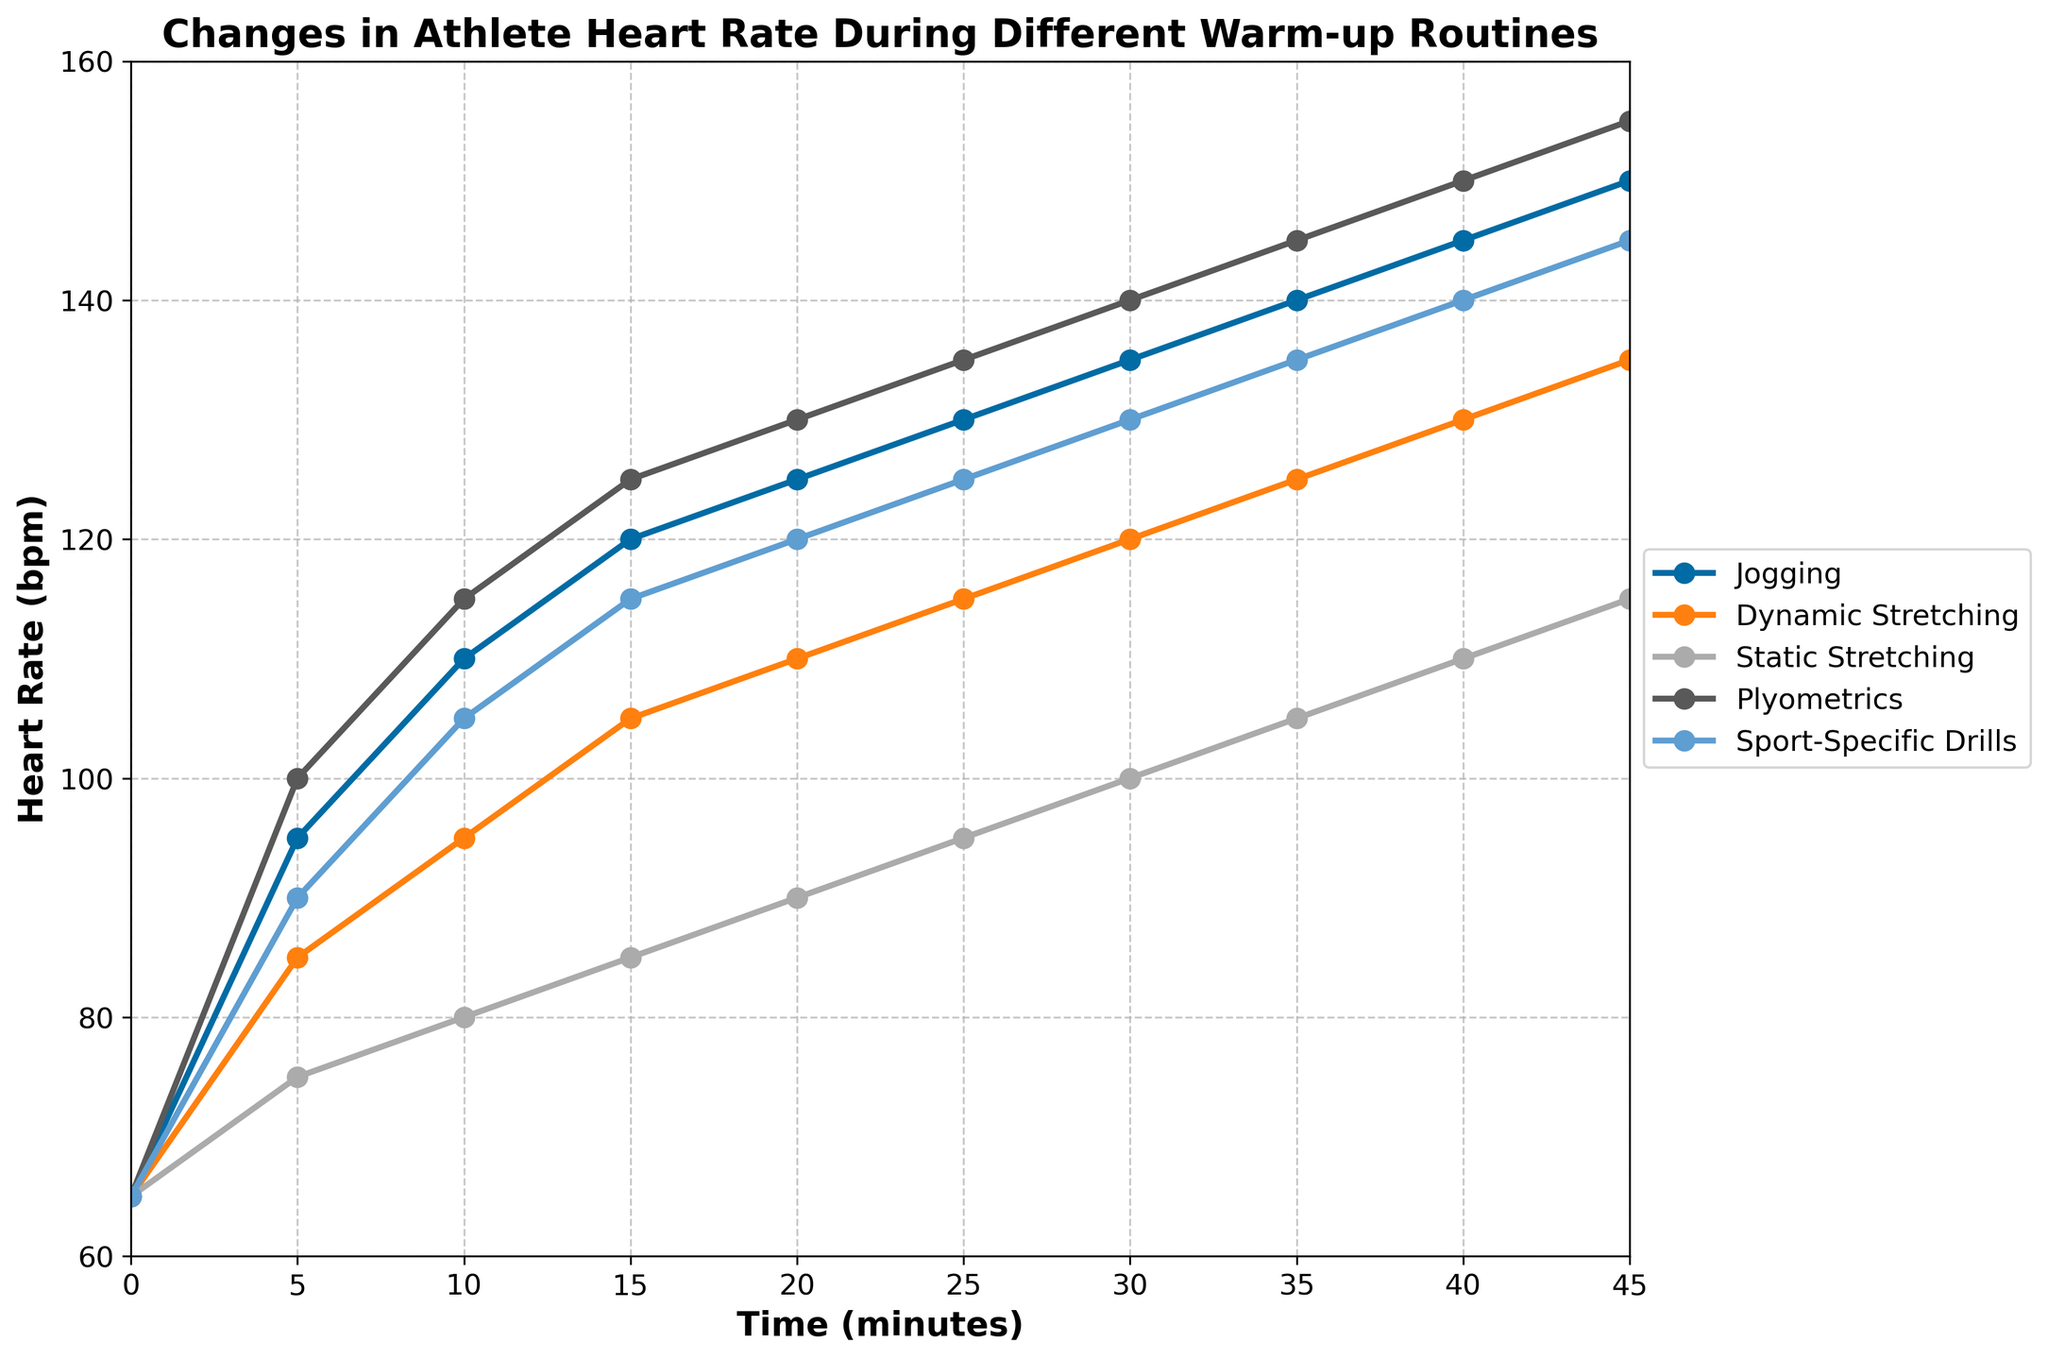what is the highest heart rate recorded during static stretching? Look for the line labeled "Static Stretching" and identify its highest point. The highest recorded heart rate for static stretching is at the 45-minute mark with a heart rate of 115 bpm.
Answer: 115 bpm Which warm-up routine shows the fastest increase in heart rate within the first 5 minutes? Compare the slopes of the lines for each warm-up routine in the first 5 minutes. Plyometrics rises from 65 bpm to 100 bpm, which is a 35 bpm increase, the highest among all.
Answer: Plyometrics At which time point do jogging and sport-specific drills have the same heart rate? Find the point where the lines for Jogging and Sport-Specific Drills intersect. At the 5-minute mark, both routines have a heart rate of 95 bpm.
Answer: 5 minutes How does the heart rate at 20 minutes compare between dynamic stretching and plyometrics? Look at the heart rates at the 20-minute mark for both routines. Dynamic stretching has a heart rate of 110 bpm, while plyometrics has 130 bpm. Plyometrics has a higher heart rate by 20 bpm.
Answer: Plyometrics is higher by 20 bpm What is the average heart rate at 30 minutes for all warm-up routines combined? Sum the heart rates of all routines at 30 minutes and divide by 5 (number of routines). The heart rates at 30 minutes are 135 (Jogging), 120 (Dynamic Stretching), 100 (Static Stretching), 140 (Plyometrics), and 130 (Sport-Specific Drills). Summing these gives 625, and dividing by 5 gives 125 bpm.
Answer: 125 bpm Which warm-up routine has the smallest change in heart rate from start to finish? Calculate the change in heart rate for each routine from 0 to 45 minutes. Jogging: 85 bpm, Dynamic Stretching: 70 bpm, Static Stretching: 50 bpm, Plyometrics: 90 bpm, Sport-Specific Drills: 80 bpm. Static Stretching has the smallest change.
Answer: Static Stretching At the 15-minute mark, which routine has the second-highest heart rate? Compare the heart rates at 15 minutes for all routines. Plyometrics has the highest at 125 bpm, and Jogging follows with 120 bpm, which is the second-highest.
Answer: Jogging What is the difference between the highest heart rate of dynamic stretching and jogging? Identify the highest points: Dynamic Stretching at 45 minutes with 135 bpm and Jogging at 45 minutes with 150 bpm. The difference is 150 - 135 = 15 bpm.
Answer: 15 bpm Does any routine have a consistent linear increase in heart rate throughout the time period? Examine the trends for each line. Jogging and Plyometrics show a fairly linear increase, but Jogging is more consistent without abrupt changes.
Answer: Jogging 